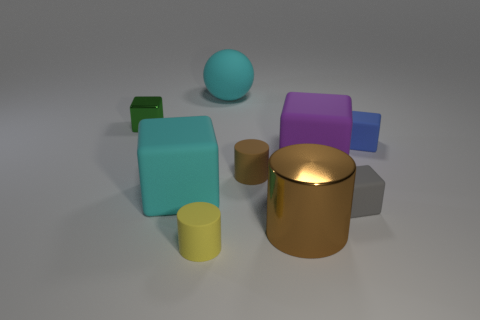How many big purple things have the same material as the small brown object?
Offer a very short reply. 1. Does the small yellow thing have the same shape as the tiny green shiny thing?
Offer a very short reply. No. What is the size of the cyan object in front of the thing to the right of the gray cube that is in front of the green thing?
Offer a very short reply. Large. There is a matte object that is behind the green block; are there any small yellow matte cylinders that are in front of it?
Give a very brief answer. Yes. There is a cube right of the gray matte cube that is in front of the big purple rubber thing; what number of tiny blocks are behind it?
Provide a short and direct response. 1. What color is the tiny matte object that is to the right of the brown matte thing and in front of the brown matte thing?
Keep it short and to the point. Gray. What number of big balls are the same color as the big metallic thing?
Give a very brief answer. 0. How many balls are either matte objects or small purple matte things?
Ensure brevity in your answer.  1. There is another matte cylinder that is the same size as the brown rubber cylinder; what color is it?
Your response must be concise. Yellow. There is a big rubber block on the right side of the thing that is behind the small green metallic cube; is there a green metal cube that is on the right side of it?
Provide a short and direct response. No. 